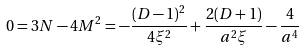Convert formula to latex. <formula><loc_0><loc_0><loc_500><loc_500>0 = 3 N - 4 M ^ { 2 } = - \frac { ( D - 1 ) ^ { 2 } } { 4 \xi ^ { 2 } } + \frac { 2 ( D + 1 ) } { a ^ { 2 } \xi } - \frac { 4 } { a ^ { 4 } }</formula> 